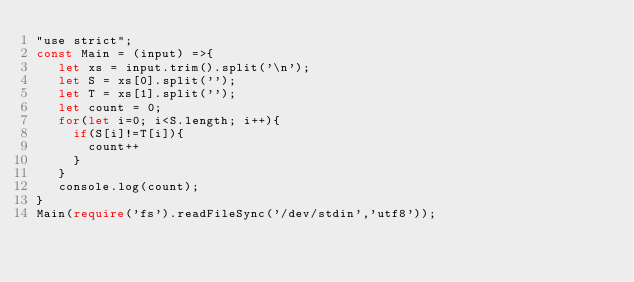<code> <loc_0><loc_0><loc_500><loc_500><_TypeScript_>"use strict";
const Main = (input) =>{
   let xs = input.trim().split('\n');
   let S = xs[0].split('');
   let T = xs[1].split('');
   let count = 0;
   for(let i=0; i<S.length; i++){
     if(S[i]!=T[i]){
       count++
     }
   }
   console.log(count);
}
Main(require('fs').readFileSync('/dev/stdin','utf8'));</code> 